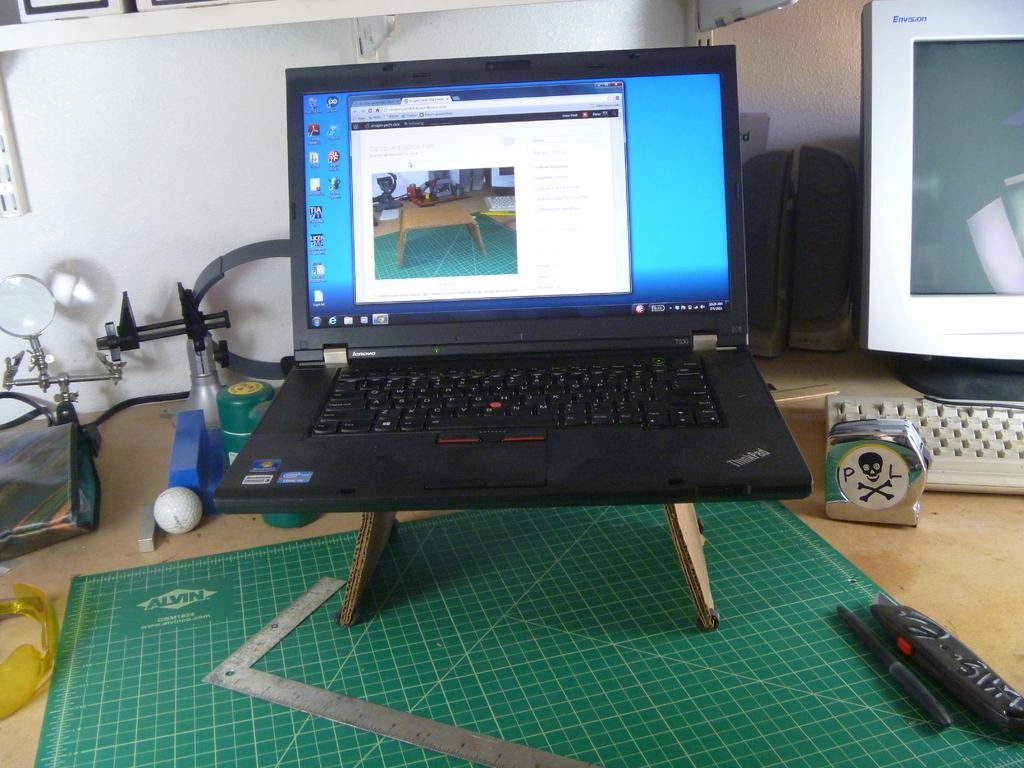This a laptop using internet?
Your answer should be compact. Yes. 